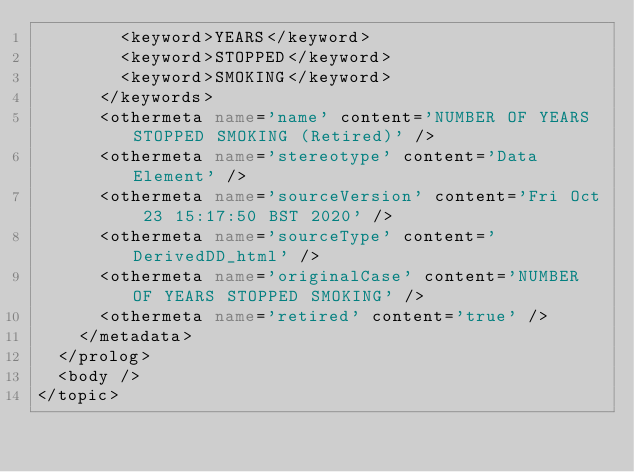<code> <loc_0><loc_0><loc_500><loc_500><_XML_>        <keyword>YEARS</keyword>
        <keyword>STOPPED</keyword>
        <keyword>SMOKING</keyword>
      </keywords>
      <othermeta name='name' content='NUMBER OF YEARS STOPPED SMOKING (Retired)' />
      <othermeta name='stereotype' content='Data Element' />
      <othermeta name='sourceVersion' content='Fri Oct 23 15:17:50 BST 2020' />
      <othermeta name='sourceType' content='DerivedDD_html' />
      <othermeta name='originalCase' content='NUMBER OF YEARS STOPPED SMOKING' />
      <othermeta name='retired' content='true' />
    </metadata>
  </prolog>
  <body />
</topic></code> 